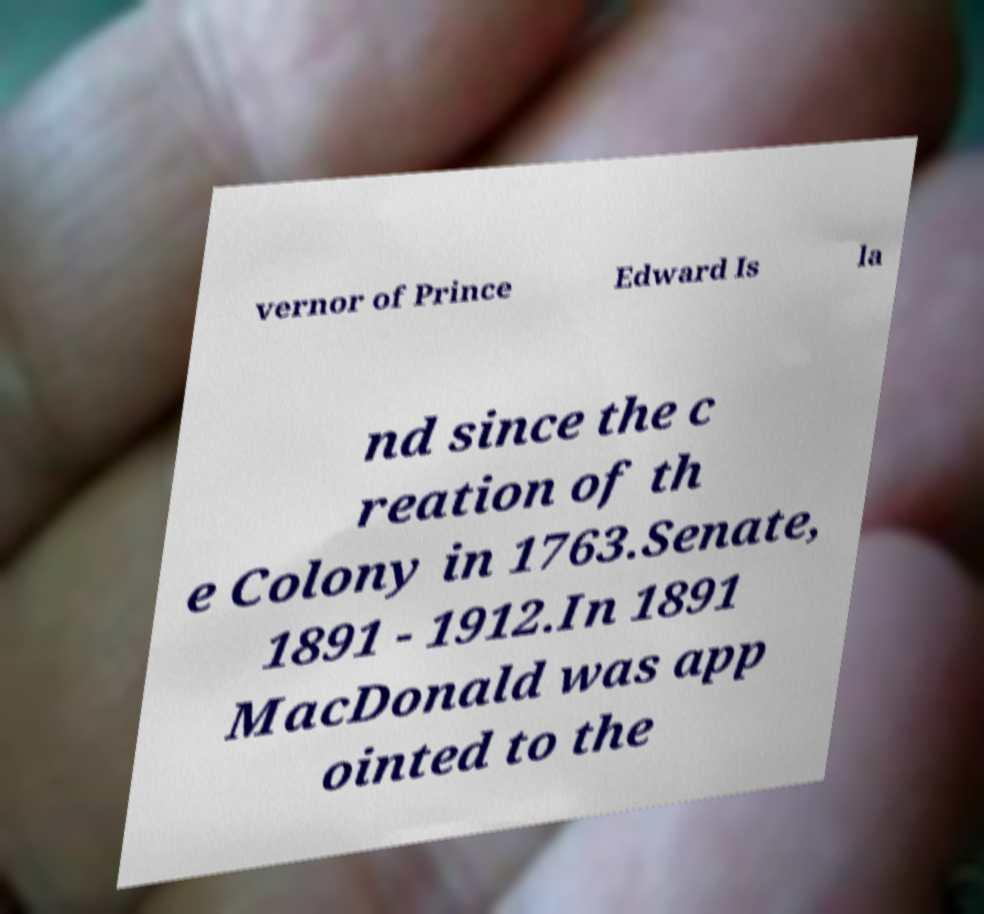There's text embedded in this image that I need extracted. Can you transcribe it verbatim? vernor of Prince Edward Is la nd since the c reation of th e Colony in 1763.Senate, 1891 - 1912.In 1891 MacDonald was app ointed to the 